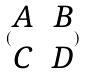<formula> <loc_0><loc_0><loc_500><loc_500>( \begin{matrix} A & B \\ C & D \end{matrix} )</formula> 